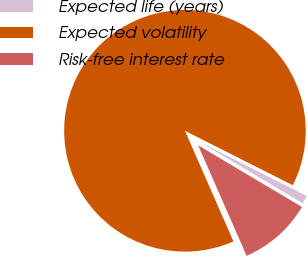<chart> <loc_0><loc_0><loc_500><loc_500><pie_chart><fcel>Expected life (years)<fcel>Expected volatility<fcel>Risk-free interest rate<nl><fcel>1.1%<fcel>89.02%<fcel>9.89%<nl></chart> 